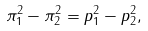Convert formula to latex. <formula><loc_0><loc_0><loc_500><loc_500>\pi _ { 1 } ^ { 2 } - \pi _ { 2 } ^ { 2 } = p _ { 1 } ^ { 2 } - p _ { 2 } ^ { 2 } ,</formula> 